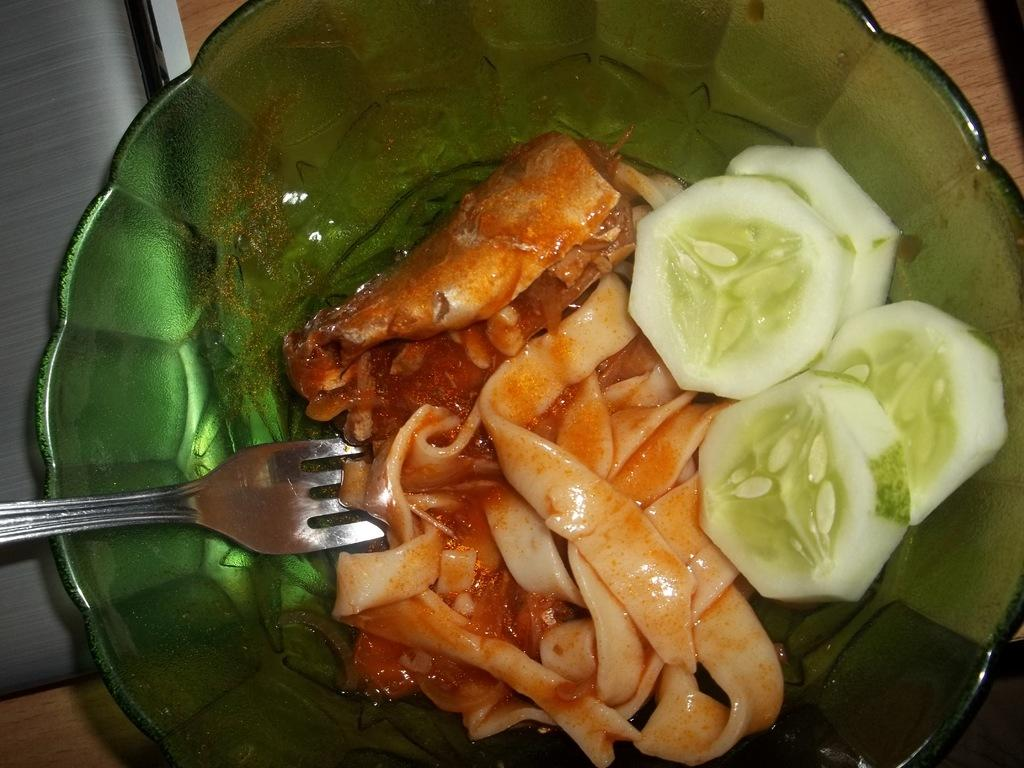What is in the bowl that is visible in the image? There is food in a bowl in the image. What utensil is visible in the image? There is a fork visible in the image. What type of furniture is present in the image? There is a table in the image. How many quarters can be seen in the image? There are no quarters present in the image. What type of feather is visible in the image? There are no feathers present in the image. 